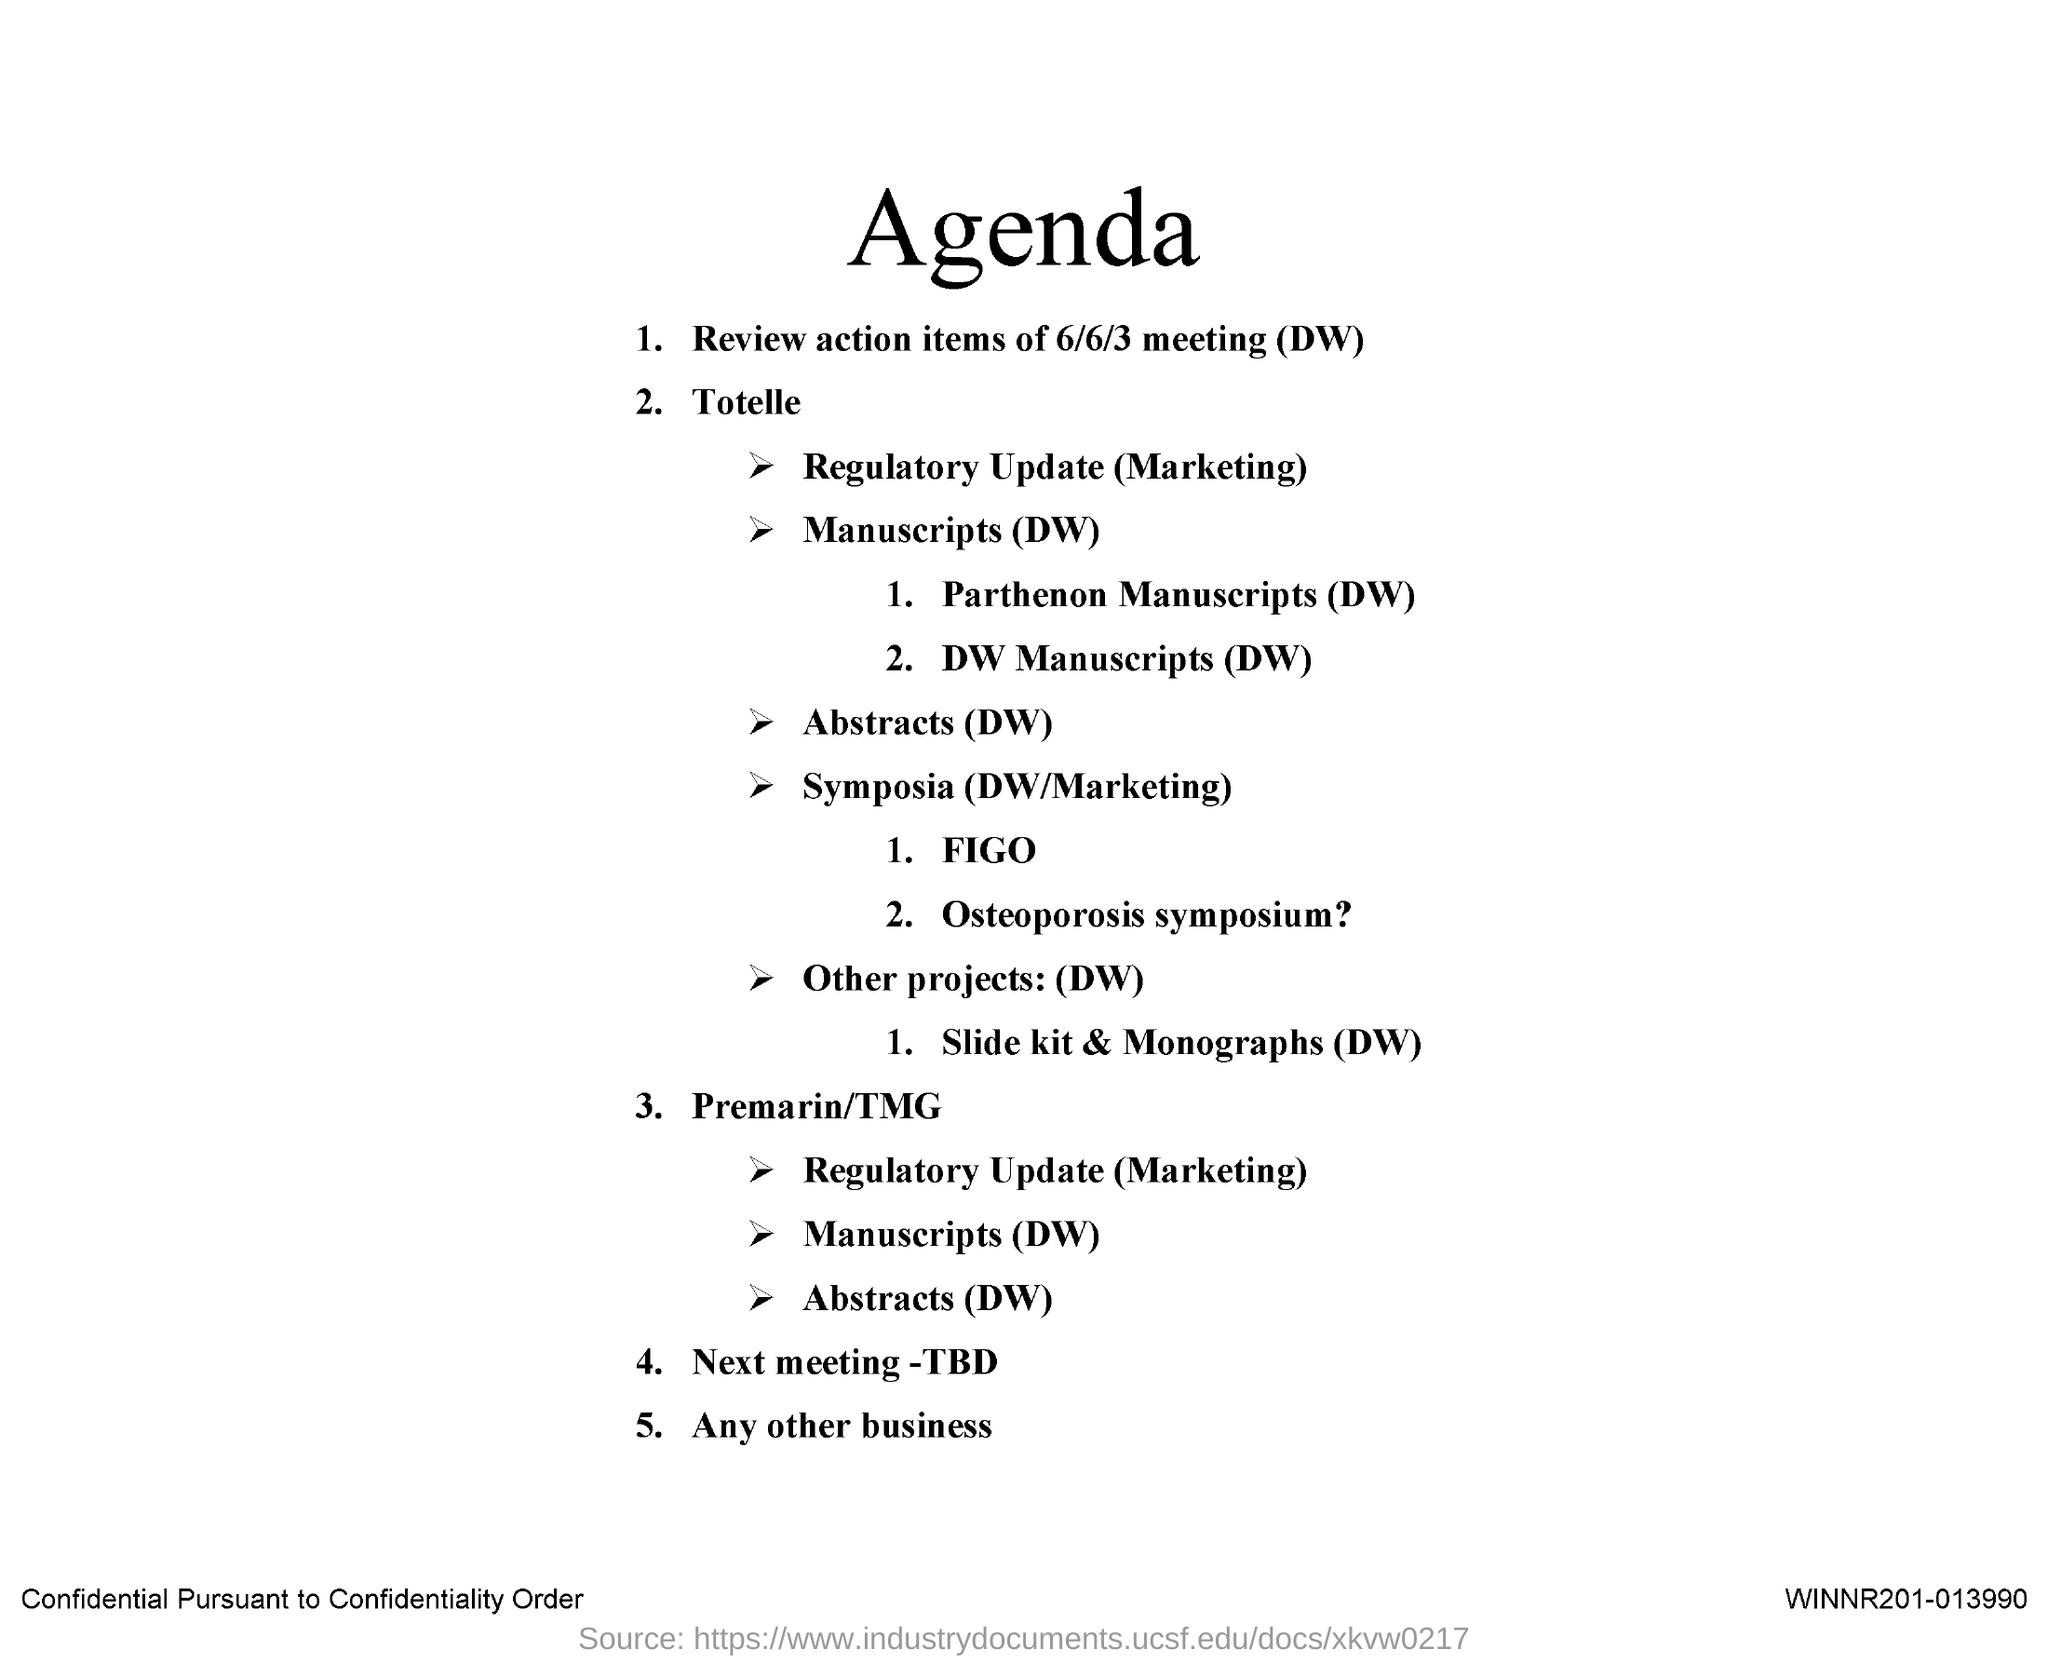What is the Title of the document?
Provide a short and direct response. Agenda. Review action items of which meeting?
Offer a terse response. 6/6/3 meeting (DW). 